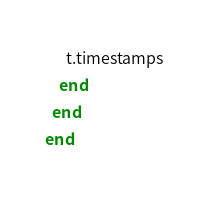Convert code to text. <code><loc_0><loc_0><loc_500><loc_500><_Ruby_>      t.timestamps
    end
  end
end
</code> 